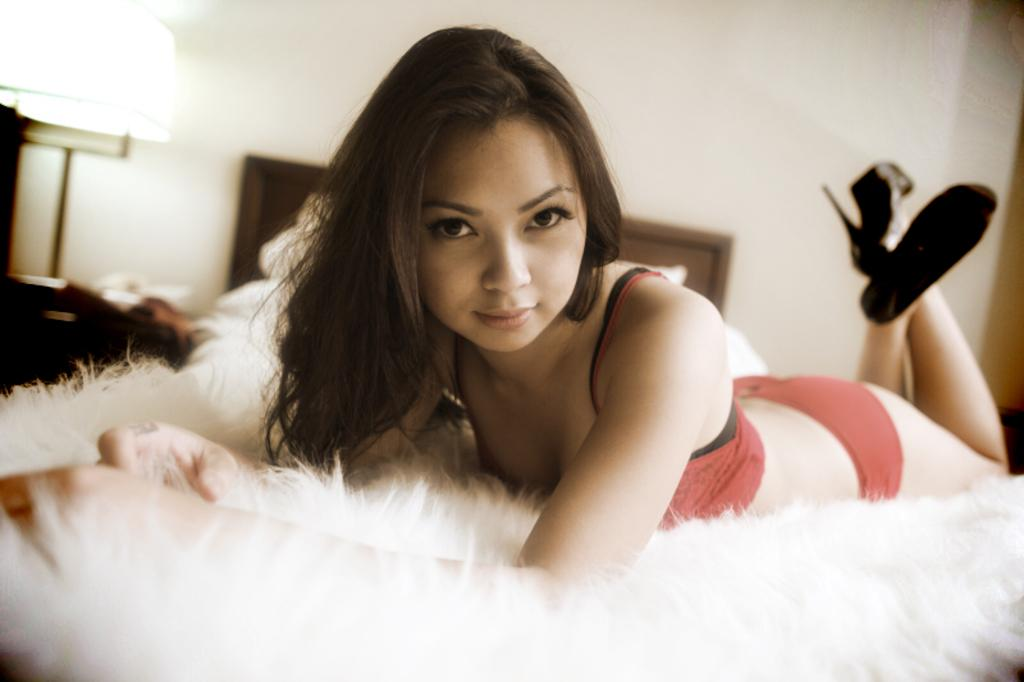What is the person in the image wearing? The person is wearing a red dress and black shoes. What is the person doing in the image? The person is sleeping on a bed. What can be seen in the background of the image? There is a lamp and a wall in the background of the image. What type of rat can be seen playing with a hose in the image? There is no rat or hose present in the image; it features a person sleeping on a bed with a lamp and a wall in the background. 